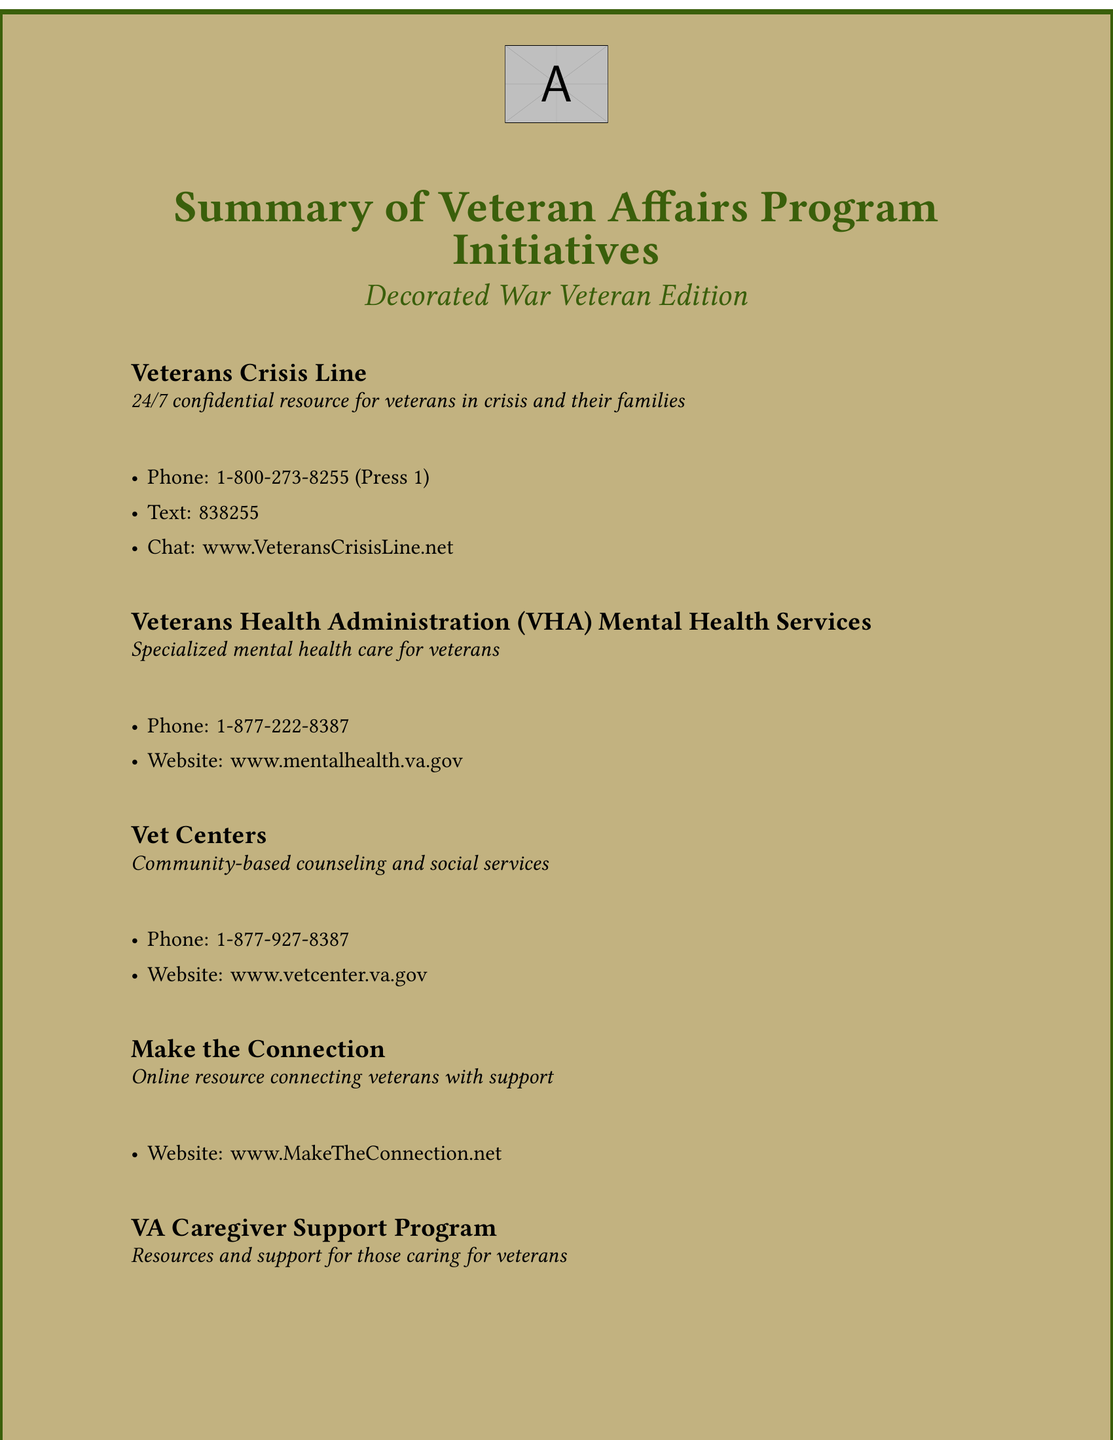What is the phone number for the Veterans Crisis Line? The phone number is explicitly stated in the document under the Veterans Crisis Line section.
Answer: 1-800-273-8255 What service does the VHA provide? The document specifies that the VHA provides specialized mental health care for veterans.
Answer: Specialized mental health care What online resource connects veterans with support? The document mentions "Make the Connection" as an online resource for veterans.
Answer: Make the Connection What is the website for the VA Caregiver Support Program? The website is listed in the document under the VA Caregiver Support Program section.
Answer: www.caregiver.va.gov How can veterans reach Vet Centers? The document notes the phone number and website as means to reach Vet Centers.
Answer: 1-877-927-8387 What type of support does the VA Caregiver Support Program offer? The document describes that the program offers resources and support for those caring for veterans.
Answer: Resources and support How many program initiatives are listed? The number of program initiatives can be counted directly from the document.
Answer: Five What is the color theme of the document? The document uses specific colors, which can be identified in its design.
Answer: Army green and sand color What is the purpose of the Veterans Crisis Line? The purpose is mentioned in the document as a resource for veterans in crisis.
Answer: Confidential resource for veterans in crisis 